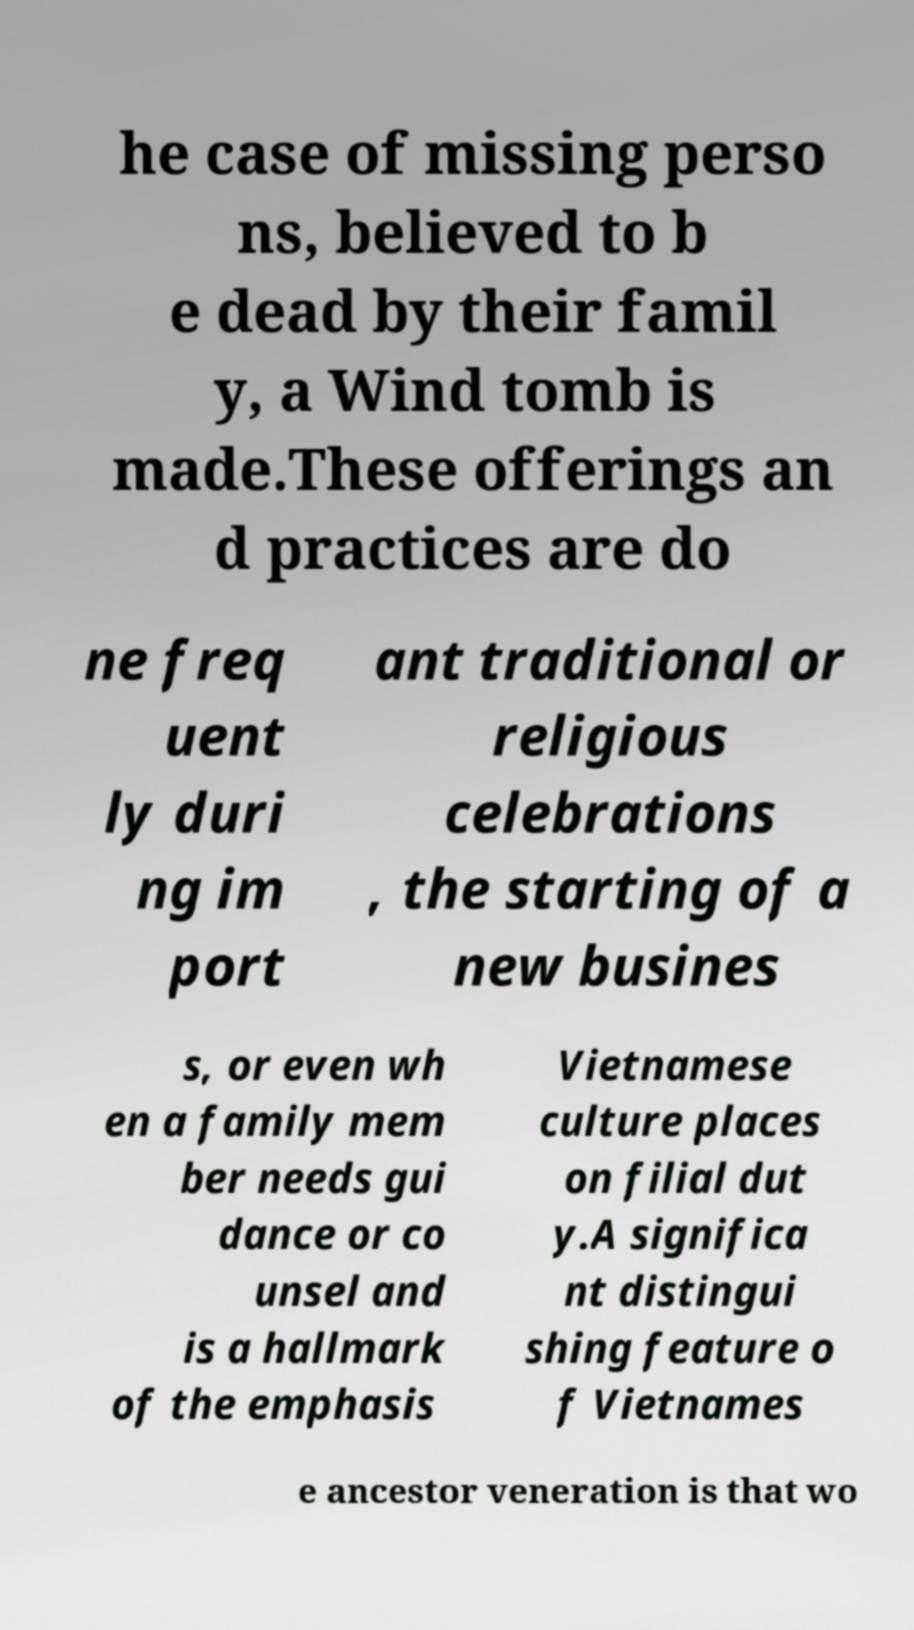Can you accurately transcribe the text from the provided image for me? he case of missing perso ns, believed to b e dead by their famil y, a Wind tomb is made.These offerings an d practices are do ne freq uent ly duri ng im port ant traditional or religious celebrations , the starting of a new busines s, or even wh en a family mem ber needs gui dance or co unsel and is a hallmark of the emphasis Vietnamese culture places on filial dut y.A significa nt distingui shing feature o f Vietnames e ancestor veneration is that wo 